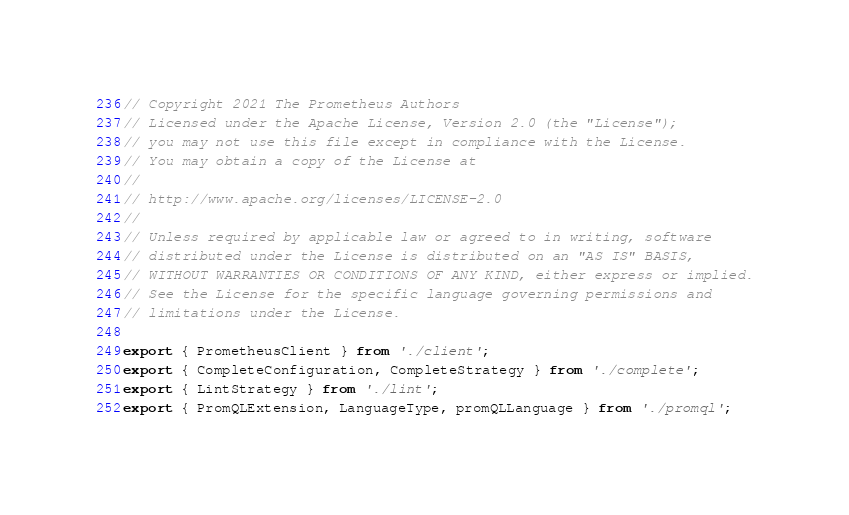Convert code to text. <code><loc_0><loc_0><loc_500><loc_500><_TypeScript_>// Copyright 2021 The Prometheus Authors
// Licensed under the Apache License, Version 2.0 (the "License");
// you may not use this file except in compliance with the License.
// You may obtain a copy of the License at
//
// http://www.apache.org/licenses/LICENSE-2.0
//
// Unless required by applicable law or agreed to in writing, software
// distributed under the License is distributed on an "AS IS" BASIS,
// WITHOUT WARRANTIES OR CONDITIONS OF ANY KIND, either express or implied.
// See the License for the specific language governing permissions and
// limitations under the License.

export { PrometheusClient } from './client';
export { CompleteConfiguration, CompleteStrategy } from './complete';
export { LintStrategy } from './lint';
export { PromQLExtension, LanguageType, promQLLanguage } from './promql';
</code> 